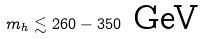Convert formula to latex. <formula><loc_0><loc_0><loc_500><loc_500>m _ { h } \lesssim 2 6 0 - 3 5 0 \text { GeV}</formula> 